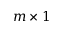Convert formula to latex. <formula><loc_0><loc_0><loc_500><loc_500>m \times 1</formula> 